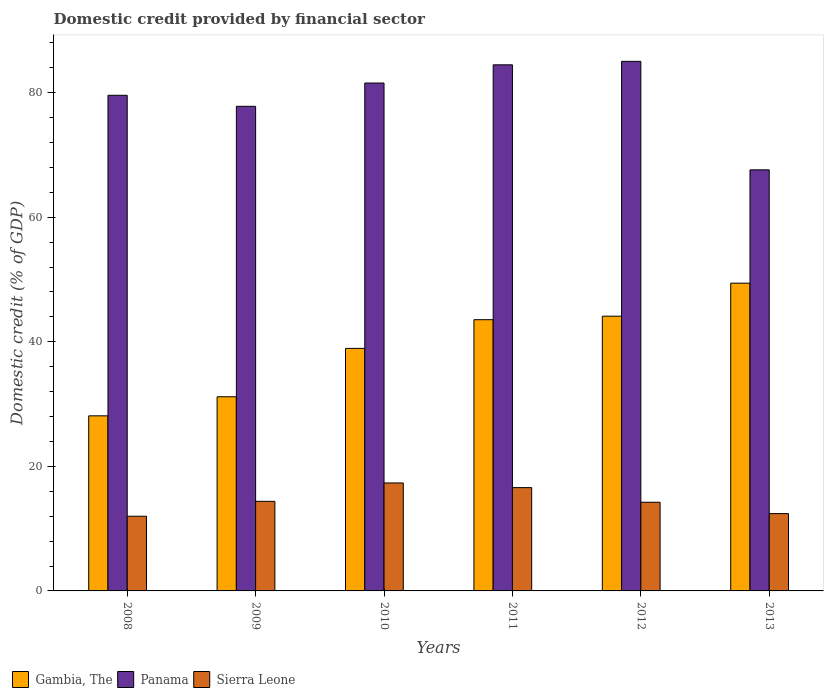Are the number of bars on each tick of the X-axis equal?
Provide a short and direct response. Yes. How many bars are there on the 1st tick from the left?
Keep it short and to the point. 3. How many bars are there on the 6th tick from the right?
Your response must be concise. 3. What is the label of the 4th group of bars from the left?
Ensure brevity in your answer.  2011. What is the domestic credit in Panama in 2010?
Your response must be concise. 81.54. Across all years, what is the maximum domestic credit in Sierra Leone?
Your response must be concise. 17.33. Across all years, what is the minimum domestic credit in Gambia, The?
Provide a short and direct response. 28.11. In which year was the domestic credit in Panama maximum?
Give a very brief answer. 2012. What is the total domestic credit in Sierra Leone in the graph?
Offer a terse response. 86.94. What is the difference between the domestic credit in Panama in 2011 and that in 2012?
Keep it short and to the point. -0.56. What is the difference between the domestic credit in Panama in 2009 and the domestic credit in Gambia, The in 2012?
Offer a terse response. 33.69. What is the average domestic credit in Sierra Leone per year?
Give a very brief answer. 14.49. In the year 2010, what is the difference between the domestic credit in Panama and domestic credit in Gambia, The?
Your answer should be very brief. 42.6. In how many years, is the domestic credit in Sierra Leone greater than 32 %?
Give a very brief answer. 0. What is the ratio of the domestic credit in Panama in 2008 to that in 2011?
Your answer should be very brief. 0.94. Is the domestic credit in Panama in 2012 less than that in 2013?
Offer a very short reply. No. What is the difference between the highest and the second highest domestic credit in Gambia, The?
Provide a short and direct response. 5.3. What is the difference between the highest and the lowest domestic credit in Gambia, The?
Make the answer very short. 21.3. Is the sum of the domestic credit in Gambia, The in 2009 and 2012 greater than the maximum domestic credit in Panama across all years?
Your answer should be compact. No. What does the 3rd bar from the left in 2010 represents?
Provide a short and direct response. Sierra Leone. What does the 2nd bar from the right in 2010 represents?
Provide a short and direct response. Panama. Is it the case that in every year, the sum of the domestic credit in Panama and domestic credit in Sierra Leone is greater than the domestic credit in Gambia, The?
Your response must be concise. Yes. How many bars are there?
Your answer should be very brief. 18. Are all the bars in the graph horizontal?
Make the answer very short. No. How many years are there in the graph?
Your response must be concise. 6. What is the difference between two consecutive major ticks on the Y-axis?
Provide a short and direct response. 20. Does the graph contain any zero values?
Your response must be concise. No. Where does the legend appear in the graph?
Provide a succinct answer. Bottom left. What is the title of the graph?
Your answer should be compact. Domestic credit provided by financial sector. Does "China" appear as one of the legend labels in the graph?
Offer a very short reply. No. What is the label or title of the Y-axis?
Offer a terse response. Domestic credit (% of GDP). What is the Domestic credit (% of GDP) of Gambia, The in 2008?
Provide a succinct answer. 28.11. What is the Domestic credit (% of GDP) of Panama in 2008?
Offer a very short reply. 79.57. What is the Domestic credit (% of GDP) in Sierra Leone in 2008?
Your answer should be compact. 11.99. What is the Domestic credit (% of GDP) in Gambia, The in 2009?
Make the answer very short. 31.17. What is the Domestic credit (% of GDP) of Panama in 2009?
Provide a short and direct response. 77.8. What is the Domestic credit (% of GDP) in Sierra Leone in 2009?
Your response must be concise. 14.39. What is the Domestic credit (% of GDP) of Gambia, The in 2010?
Your answer should be very brief. 38.94. What is the Domestic credit (% of GDP) in Panama in 2010?
Your answer should be very brief. 81.54. What is the Domestic credit (% of GDP) of Sierra Leone in 2010?
Your response must be concise. 17.33. What is the Domestic credit (% of GDP) in Gambia, The in 2011?
Keep it short and to the point. 43.55. What is the Domestic credit (% of GDP) of Panama in 2011?
Your answer should be very brief. 84.46. What is the Domestic credit (% of GDP) of Sierra Leone in 2011?
Give a very brief answer. 16.58. What is the Domestic credit (% of GDP) in Gambia, The in 2012?
Give a very brief answer. 44.11. What is the Domestic credit (% of GDP) of Panama in 2012?
Provide a succinct answer. 85.02. What is the Domestic credit (% of GDP) in Sierra Leone in 2012?
Make the answer very short. 14.24. What is the Domestic credit (% of GDP) in Gambia, The in 2013?
Offer a very short reply. 49.41. What is the Domestic credit (% of GDP) of Panama in 2013?
Your answer should be compact. 67.6. What is the Domestic credit (% of GDP) in Sierra Leone in 2013?
Keep it short and to the point. 12.41. Across all years, what is the maximum Domestic credit (% of GDP) of Gambia, The?
Ensure brevity in your answer.  49.41. Across all years, what is the maximum Domestic credit (% of GDP) in Panama?
Your response must be concise. 85.02. Across all years, what is the maximum Domestic credit (% of GDP) in Sierra Leone?
Keep it short and to the point. 17.33. Across all years, what is the minimum Domestic credit (% of GDP) of Gambia, The?
Your response must be concise. 28.11. Across all years, what is the minimum Domestic credit (% of GDP) in Panama?
Offer a terse response. 67.6. Across all years, what is the minimum Domestic credit (% of GDP) of Sierra Leone?
Give a very brief answer. 11.99. What is the total Domestic credit (% of GDP) of Gambia, The in the graph?
Make the answer very short. 235.28. What is the total Domestic credit (% of GDP) in Panama in the graph?
Keep it short and to the point. 476. What is the total Domestic credit (% of GDP) of Sierra Leone in the graph?
Give a very brief answer. 86.94. What is the difference between the Domestic credit (% of GDP) in Gambia, The in 2008 and that in 2009?
Give a very brief answer. -3.06. What is the difference between the Domestic credit (% of GDP) in Panama in 2008 and that in 2009?
Provide a short and direct response. 1.77. What is the difference between the Domestic credit (% of GDP) of Sierra Leone in 2008 and that in 2009?
Provide a succinct answer. -2.39. What is the difference between the Domestic credit (% of GDP) in Gambia, The in 2008 and that in 2010?
Provide a succinct answer. -10.83. What is the difference between the Domestic credit (% of GDP) in Panama in 2008 and that in 2010?
Give a very brief answer. -1.97. What is the difference between the Domestic credit (% of GDP) of Sierra Leone in 2008 and that in 2010?
Your answer should be compact. -5.34. What is the difference between the Domestic credit (% of GDP) in Gambia, The in 2008 and that in 2011?
Keep it short and to the point. -15.44. What is the difference between the Domestic credit (% of GDP) in Panama in 2008 and that in 2011?
Offer a very short reply. -4.89. What is the difference between the Domestic credit (% of GDP) of Sierra Leone in 2008 and that in 2011?
Offer a very short reply. -4.59. What is the difference between the Domestic credit (% of GDP) of Gambia, The in 2008 and that in 2012?
Provide a short and direct response. -16. What is the difference between the Domestic credit (% of GDP) in Panama in 2008 and that in 2012?
Offer a very short reply. -5.45. What is the difference between the Domestic credit (% of GDP) of Sierra Leone in 2008 and that in 2012?
Give a very brief answer. -2.24. What is the difference between the Domestic credit (% of GDP) of Gambia, The in 2008 and that in 2013?
Ensure brevity in your answer.  -21.3. What is the difference between the Domestic credit (% of GDP) of Panama in 2008 and that in 2013?
Make the answer very short. 11.97. What is the difference between the Domestic credit (% of GDP) of Sierra Leone in 2008 and that in 2013?
Make the answer very short. -0.42. What is the difference between the Domestic credit (% of GDP) in Gambia, The in 2009 and that in 2010?
Give a very brief answer. -7.77. What is the difference between the Domestic credit (% of GDP) in Panama in 2009 and that in 2010?
Provide a short and direct response. -3.74. What is the difference between the Domestic credit (% of GDP) in Sierra Leone in 2009 and that in 2010?
Offer a very short reply. -2.95. What is the difference between the Domestic credit (% of GDP) in Gambia, The in 2009 and that in 2011?
Ensure brevity in your answer.  -12.37. What is the difference between the Domestic credit (% of GDP) of Panama in 2009 and that in 2011?
Give a very brief answer. -6.66. What is the difference between the Domestic credit (% of GDP) in Sierra Leone in 2009 and that in 2011?
Offer a terse response. -2.2. What is the difference between the Domestic credit (% of GDP) of Gambia, The in 2009 and that in 2012?
Provide a succinct answer. -12.94. What is the difference between the Domestic credit (% of GDP) in Panama in 2009 and that in 2012?
Make the answer very short. -7.22. What is the difference between the Domestic credit (% of GDP) of Sierra Leone in 2009 and that in 2012?
Your response must be concise. 0.15. What is the difference between the Domestic credit (% of GDP) in Gambia, The in 2009 and that in 2013?
Provide a short and direct response. -18.24. What is the difference between the Domestic credit (% of GDP) in Panama in 2009 and that in 2013?
Offer a very short reply. 10.2. What is the difference between the Domestic credit (% of GDP) in Sierra Leone in 2009 and that in 2013?
Ensure brevity in your answer.  1.97. What is the difference between the Domestic credit (% of GDP) in Gambia, The in 2010 and that in 2011?
Provide a succinct answer. -4.61. What is the difference between the Domestic credit (% of GDP) of Panama in 2010 and that in 2011?
Ensure brevity in your answer.  -2.92. What is the difference between the Domestic credit (% of GDP) in Sierra Leone in 2010 and that in 2011?
Give a very brief answer. 0.75. What is the difference between the Domestic credit (% of GDP) in Gambia, The in 2010 and that in 2012?
Your response must be concise. -5.17. What is the difference between the Domestic credit (% of GDP) in Panama in 2010 and that in 2012?
Your answer should be very brief. -3.48. What is the difference between the Domestic credit (% of GDP) of Sierra Leone in 2010 and that in 2012?
Offer a very short reply. 3.1. What is the difference between the Domestic credit (% of GDP) of Gambia, The in 2010 and that in 2013?
Keep it short and to the point. -10.47. What is the difference between the Domestic credit (% of GDP) of Panama in 2010 and that in 2013?
Make the answer very short. 13.94. What is the difference between the Domestic credit (% of GDP) of Sierra Leone in 2010 and that in 2013?
Give a very brief answer. 4.92. What is the difference between the Domestic credit (% of GDP) in Gambia, The in 2011 and that in 2012?
Your response must be concise. -0.56. What is the difference between the Domestic credit (% of GDP) of Panama in 2011 and that in 2012?
Give a very brief answer. -0.56. What is the difference between the Domestic credit (% of GDP) of Sierra Leone in 2011 and that in 2012?
Give a very brief answer. 2.35. What is the difference between the Domestic credit (% of GDP) in Gambia, The in 2011 and that in 2013?
Give a very brief answer. -5.86. What is the difference between the Domestic credit (% of GDP) of Panama in 2011 and that in 2013?
Your answer should be compact. 16.86. What is the difference between the Domestic credit (% of GDP) in Sierra Leone in 2011 and that in 2013?
Give a very brief answer. 4.17. What is the difference between the Domestic credit (% of GDP) of Gambia, The in 2012 and that in 2013?
Your answer should be very brief. -5.3. What is the difference between the Domestic credit (% of GDP) in Panama in 2012 and that in 2013?
Provide a succinct answer. 17.42. What is the difference between the Domestic credit (% of GDP) of Sierra Leone in 2012 and that in 2013?
Make the answer very short. 1.82. What is the difference between the Domestic credit (% of GDP) in Gambia, The in 2008 and the Domestic credit (% of GDP) in Panama in 2009?
Your response must be concise. -49.69. What is the difference between the Domestic credit (% of GDP) in Gambia, The in 2008 and the Domestic credit (% of GDP) in Sierra Leone in 2009?
Give a very brief answer. 13.72. What is the difference between the Domestic credit (% of GDP) of Panama in 2008 and the Domestic credit (% of GDP) of Sierra Leone in 2009?
Keep it short and to the point. 65.19. What is the difference between the Domestic credit (% of GDP) of Gambia, The in 2008 and the Domestic credit (% of GDP) of Panama in 2010?
Offer a very short reply. -53.43. What is the difference between the Domestic credit (% of GDP) in Gambia, The in 2008 and the Domestic credit (% of GDP) in Sierra Leone in 2010?
Provide a short and direct response. 10.78. What is the difference between the Domestic credit (% of GDP) in Panama in 2008 and the Domestic credit (% of GDP) in Sierra Leone in 2010?
Your answer should be very brief. 62.24. What is the difference between the Domestic credit (% of GDP) of Gambia, The in 2008 and the Domestic credit (% of GDP) of Panama in 2011?
Keep it short and to the point. -56.35. What is the difference between the Domestic credit (% of GDP) in Gambia, The in 2008 and the Domestic credit (% of GDP) in Sierra Leone in 2011?
Ensure brevity in your answer.  11.53. What is the difference between the Domestic credit (% of GDP) in Panama in 2008 and the Domestic credit (% of GDP) in Sierra Leone in 2011?
Give a very brief answer. 62.99. What is the difference between the Domestic credit (% of GDP) of Gambia, The in 2008 and the Domestic credit (% of GDP) of Panama in 2012?
Provide a short and direct response. -56.91. What is the difference between the Domestic credit (% of GDP) of Gambia, The in 2008 and the Domestic credit (% of GDP) of Sierra Leone in 2012?
Your response must be concise. 13.87. What is the difference between the Domestic credit (% of GDP) in Panama in 2008 and the Domestic credit (% of GDP) in Sierra Leone in 2012?
Provide a succinct answer. 65.34. What is the difference between the Domestic credit (% of GDP) in Gambia, The in 2008 and the Domestic credit (% of GDP) in Panama in 2013?
Offer a very short reply. -39.49. What is the difference between the Domestic credit (% of GDP) of Gambia, The in 2008 and the Domestic credit (% of GDP) of Sierra Leone in 2013?
Give a very brief answer. 15.7. What is the difference between the Domestic credit (% of GDP) in Panama in 2008 and the Domestic credit (% of GDP) in Sierra Leone in 2013?
Offer a terse response. 67.16. What is the difference between the Domestic credit (% of GDP) in Gambia, The in 2009 and the Domestic credit (% of GDP) in Panama in 2010?
Give a very brief answer. -50.37. What is the difference between the Domestic credit (% of GDP) in Gambia, The in 2009 and the Domestic credit (% of GDP) in Sierra Leone in 2010?
Your answer should be compact. 13.84. What is the difference between the Domestic credit (% of GDP) in Panama in 2009 and the Domestic credit (% of GDP) in Sierra Leone in 2010?
Provide a succinct answer. 60.47. What is the difference between the Domestic credit (% of GDP) of Gambia, The in 2009 and the Domestic credit (% of GDP) of Panama in 2011?
Make the answer very short. -53.29. What is the difference between the Domestic credit (% of GDP) in Gambia, The in 2009 and the Domestic credit (% of GDP) in Sierra Leone in 2011?
Give a very brief answer. 14.59. What is the difference between the Domestic credit (% of GDP) in Panama in 2009 and the Domestic credit (% of GDP) in Sierra Leone in 2011?
Your answer should be very brief. 61.22. What is the difference between the Domestic credit (% of GDP) in Gambia, The in 2009 and the Domestic credit (% of GDP) in Panama in 2012?
Ensure brevity in your answer.  -53.85. What is the difference between the Domestic credit (% of GDP) in Gambia, The in 2009 and the Domestic credit (% of GDP) in Sierra Leone in 2012?
Give a very brief answer. 16.94. What is the difference between the Domestic credit (% of GDP) in Panama in 2009 and the Domestic credit (% of GDP) in Sierra Leone in 2012?
Offer a very short reply. 63.57. What is the difference between the Domestic credit (% of GDP) in Gambia, The in 2009 and the Domestic credit (% of GDP) in Panama in 2013?
Your response must be concise. -36.43. What is the difference between the Domestic credit (% of GDP) of Gambia, The in 2009 and the Domestic credit (% of GDP) of Sierra Leone in 2013?
Ensure brevity in your answer.  18.76. What is the difference between the Domestic credit (% of GDP) in Panama in 2009 and the Domestic credit (% of GDP) in Sierra Leone in 2013?
Give a very brief answer. 65.39. What is the difference between the Domestic credit (% of GDP) in Gambia, The in 2010 and the Domestic credit (% of GDP) in Panama in 2011?
Offer a terse response. -45.53. What is the difference between the Domestic credit (% of GDP) of Gambia, The in 2010 and the Domestic credit (% of GDP) of Sierra Leone in 2011?
Your answer should be very brief. 22.35. What is the difference between the Domestic credit (% of GDP) of Panama in 2010 and the Domestic credit (% of GDP) of Sierra Leone in 2011?
Offer a terse response. 64.96. What is the difference between the Domestic credit (% of GDP) in Gambia, The in 2010 and the Domestic credit (% of GDP) in Panama in 2012?
Keep it short and to the point. -46.08. What is the difference between the Domestic credit (% of GDP) of Gambia, The in 2010 and the Domestic credit (% of GDP) of Sierra Leone in 2012?
Your answer should be very brief. 24.7. What is the difference between the Domestic credit (% of GDP) of Panama in 2010 and the Domestic credit (% of GDP) of Sierra Leone in 2012?
Give a very brief answer. 67.3. What is the difference between the Domestic credit (% of GDP) in Gambia, The in 2010 and the Domestic credit (% of GDP) in Panama in 2013?
Provide a succinct answer. -28.66. What is the difference between the Domestic credit (% of GDP) of Gambia, The in 2010 and the Domestic credit (% of GDP) of Sierra Leone in 2013?
Your answer should be compact. 26.53. What is the difference between the Domestic credit (% of GDP) in Panama in 2010 and the Domestic credit (% of GDP) in Sierra Leone in 2013?
Your response must be concise. 69.13. What is the difference between the Domestic credit (% of GDP) of Gambia, The in 2011 and the Domestic credit (% of GDP) of Panama in 2012?
Keep it short and to the point. -41.48. What is the difference between the Domestic credit (% of GDP) in Gambia, The in 2011 and the Domestic credit (% of GDP) in Sierra Leone in 2012?
Your answer should be compact. 29.31. What is the difference between the Domestic credit (% of GDP) in Panama in 2011 and the Domestic credit (% of GDP) in Sierra Leone in 2012?
Your answer should be compact. 70.23. What is the difference between the Domestic credit (% of GDP) of Gambia, The in 2011 and the Domestic credit (% of GDP) of Panama in 2013?
Offer a terse response. -24.06. What is the difference between the Domestic credit (% of GDP) of Gambia, The in 2011 and the Domestic credit (% of GDP) of Sierra Leone in 2013?
Provide a succinct answer. 31.13. What is the difference between the Domestic credit (% of GDP) in Panama in 2011 and the Domestic credit (% of GDP) in Sierra Leone in 2013?
Make the answer very short. 72.05. What is the difference between the Domestic credit (% of GDP) of Gambia, The in 2012 and the Domestic credit (% of GDP) of Panama in 2013?
Offer a terse response. -23.49. What is the difference between the Domestic credit (% of GDP) of Gambia, The in 2012 and the Domestic credit (% of GDP) of Sierra Leone in 2013?
Make the answer very short. 31.69. What is the difference between the Domestic credit (% of GDP) of Panama in 2012 and the Domestic credit (% of GDP) of Sierra Leone in 2013?
Your response must be concise. 72.61. What is the average Domestic credit (% of GDP) of Gambia, The per year?
Your response must be concise. 39.21. What is the average Domestic credit (% of GDP) in Panama per year?
Your answer should be compact. 79.33. What is the average Domestic credit (% of GDP) in Sierra Leone per year?
Ensure brevity in your answer.  14.49. In the year 2008, what is the difference between the Domestic credit (% of GDP) in Gambia, The and Domestic credit (% of GDP) in Panama?
Your answer should be very brief. -51.46. In the year 2008, what is the difference between the Domestic credit (% of GDP) of Gambia, The and Domestic credit (% of GDP) of Sierra Leone?
Offer a very short reply. 16.12. In the year 2008, what is the difference between the Domestic credit (% of GDP) of Panama and Domestic credit (% of GDP) of Sierra Leone?
Your answer should be compact. 67.58. In the year 2009, what is the difference between the Domestic credit (% of GDP) in Gambia, The and Domestic credit (% of GDP) in Panama?
Keep it short and to the point. -46.63. In the year 2009, what is the difference between the Domestic credit (% of GDP) of Gambia, The and Domestic credit (% of GDP) of Sierra Leone?
Make the answer very short. 16.79. In the year 2009, what is the difference between the Domestic credit (% of GDP) in Panama and Domestic credit (% of GDP) in Sierra Leone?
Your answer should be very brief. 63.42. In the year 2010, what is the difference between the Domestic credit (% of GDP) of Gambia, The and Domestic credit (% of GDP) of Panama?
Offer a very short reply. -42.6. In the year 2010, what is the difference between the Domestic credit (% of GDP) in Gambia, The and Domestic credit (% of GDP) in Sierra Leone?
Provide a short and direct response. 21.6. In the year 2010, what is the difference between the Domestic credit (% of GDP) of Panama and Domestic credit (% of GDP) of Sierra Leone?
Provide a succinct answer. 64.21. In the year 2011, what is the difference between the Domestic credit (% of GDP) in Gambia, The and Domestic credit (% of GDP) in Panama?
Provide a short and direct response. -40.92. In the year 2011, what is the difference between the Domestic credit (% of GDP) in Gambia, The and Domestic credit (% of GDP) in Sierra Leone?
Your answer should be compact. 26.96. In the year 2011, what is the difference between the Domestic credit (% of GDP) of Panama and Domestic credit (% of GDP) of Sierra Leone?
Provide a succinct answer. 67.88. In the year 2012, what is the difference between the Domestic credit (% of GDP) of Gambia, The and Domestic credit (% of GDP) of Panama?
Provide a succinct answer. -40.91. In the year 2012, what is the difference between the Domestic credit (% of GDP) of Gambia, The and Domestic credit (% of GDP) of Sierra Leone?
Offer a very short reply. 29.87. In the year 2012, what is the difference between the Domestic credit (% of GDP) in Panama and Domestic credit (% of GDP) in Sierra Leone?
Your answer should be compact. 70.78. In the year 2013, what is the difference between the Domestic credit (% of GDP) of Gambia, The and Domestic credit (% of GDP) of Panama?
Offer a terse response. -18.19. In the year 2013, what is the difference between the Domestic credit (% of GDP) in Gambia, The and Domestic credit (% of GDP) in Sierra Leone?
Offer a terse response. 37. In the year 2013, what is the difference between the Domestic credit (% of GDP) of Panama and Domestic credit (% of GDP) of Sierra Leone?
Give a very brief answer. 55.19. What is the ratio of the Domestic credit (% of GDP) in Gambia, The in 2008 to that in 2009?
Your response must be concise. 0.9. What is the ratio of the Domestic credit (% of GDP) in Panama in 2008 to that in 2009?
Your answer should be very brief. 1.02. What is the ratio of the Domestic credit (% of GDP) of Sierra Leone in 2008 to that in 2009?
Provide a succinct answer. 0.83. What is the ratio of the Domestic credit (% of GDP) in Gambia, The in 2008 to that in 2010?
Provide a short and direct response. 0.72. What is the ratio of the Domestic credit (% of GDP) of Panama in 2008 to that in 2010?
Ensure brevity in your answer.  0.98. What is the ratio of the Domestic credit (% of GDP) in Sierra Leone in 2008 to that in 2010?
Keep it short and to the point. 0.69. What is the ratio of the Domestic credit (% of GDP) of Gambia, The in 2008 to that in 2011?
Offer a terse response. 0.65. What is the ratio of the Domestic credit (% of GDP) of Panama in 2008 to that in 2011?
Your response must be concise. 0.94. What is the ratio of the Domestic credit (% of GDP) in Sierra Leone in 2008 to that in 2011?
Ensure brevity in your answer.  0.72. What is the ratio of the Domestic credit (% of GDP) in Gambia, The in 2008 to that in 2012?
Provide a short and direct response. 0.64. What is the ratio of the Domestic credit (% of GDP) in Panama in 2008 to that in 2012?
Provide a succinct answer. 0.94. What is the ratio of the Domestic credit (% of GDP) in Sierra Leone in 2008 to that in 2012?
Your answer should be compact. 0.84. What is the ratio of the Domestic credit (% of GDP) in Gambia, The in 2008 to that in 2013?
Give a very brief answer. 0.57. What is the ratio of the Domestic credit (% of GDP) in Panama in 2008 to that in 2013?
Make the answer very short. 1.18. What is the ratio of the Domestic credit (% of GDP) in Gambia, The in 2009 to that in 2010?
Your answer should be compact. 0.8. What is the ratio of the Domestic credit (% of GDP) in Panama in 2009 to that in 2010?
Your response must be concise. 0.95. What is the ratio of the Domestic credit (% of GDP) of Sierra Leone in 2009 to that in 2010?
Provide a short and direct response. 0.83. What is the ratio of the Domestic credit (% of GDP) of Gambia, The in 2009 to that in 2011?
Offer a terse response. 0.72. What is the ratio of the Domestic credit (% of GDP) of Panama in 2009 to that in 2011?
Offer a very short reply. 0.92. What is the ratio of the Domestic credit (% of GDP) of Sierra Leone in 2009 to that in 2011?
Your answer should be very brief. 0.87. What is the ratio of the Domestic credit (% of GDP) in Gambia, The in 2009 to that in 2012?
Make the answer very short. 0.71. What is the ratio of the Domestic credit (% of GDP) in Panama in 2009 to that in 2012?
Your answer should be very brief. 0.92. What is the ratio of the Domestic credit (% of GDP) of Sierra Leone in 2009 to that in 2012?
Your response must be concise. 1.01. What is the ratio of the Domestic credit (% of GDP) in Gambia, The in 2009 to that in 2013?
Offer a very short reply. 0.63. What is the ratio of the Domestic credit (% of GDP) in Panama in 2009 to that in 2013?
Provide a succinct answer. 1.15. What is the ratio of the Domestic credit (% of GDP) in Sierra Leone in 2009 to that in 2013?
Your answer should be compact. 1.16. What is the ratio of the Domestic credit (% of GDP) of Gambia, The in 2010 to that in 2011?
Offer a terse response. 0.89. What is the ratio of the Domestic credit (% of GDP) in Panama in 2010 to that in 2011?
Offer a terse response. 0.97. What is the ratio of the Domestic credit (% of GDP) in Sierra Leone in 2010 to that in 2011?
Your answer should be compact. 1.05. What is the ratio of the Domestic credit (% of GDP) in Gambia, The in 2010 to that in 2012?
Make the answer very short. 0.88. What is the ratio of the Domestic credit (% of GDP) of Panama in 2010 to that in 2012?
Provide a succinct answer. 0.96. What is the ratio of the Domestic credit (% of GDP) of Sierra Leone in 2010 to that in 2012?
Offer a very short reply. 1.22. What is the ratio of the Domestic credit (% of GDP) in Gambia, The in 2010 to that in 2013?
Offer a terse response. 0.79. What is the ratio of the Domestic credit (% of GDP) in Panama in 2010 to that in 2013?
Offer a terse response. 1.21. What is the ratio of the Domestic credit (% of GDP) in Sierra Leone in 2010 to that in 2013?
Offer a very short reply. 1.4. What is the ratio of the Domestic credit (% of GDP) in Gambia, The in 2011 to that in 2012?
Your answer should be very brief. 0.99. What is the ratio of the Domestic credit (% of GDP) of Sierra Leone in 2011 to that in 2012?
Your answer should be compact. 1.17. What is the ratio of the Domestic credit (% of GDP) in Gambia, The in 2011 to that in 2013?
Your answer should be compact. 0.88. What is the ratio of the Domestic credit (% of GDP) in Panama in 2011 to that in 2013?
Ensure brevity in your answer.  1.25. What is the ratio of the Domestic credit (% of GDP) of Sierra Leone in 2011 to that in 2013?
Make the answer very short. 1.34. What is the ratio of the Domestic credit (% of GDP) of Gambia, The in 2012 to that in 2013?
Provide a succinct answer. 0.89. What is the ratio of the Domestic credit (% of GDP) of Panama in 2012 to that in 2013?
Keep it short and to the point. 1.26. What is the ratio of the Domestic credit (% of GDP) in Sierra Leone in 2012 to that in 2013?
Your answer should be very brief. 1.15. What is the difference between the highest and the second highest Domestic credit (% of GDP) in Gambia, The?
Provide a succinct answer. 5.3. What is the difference between the highest and the second highest Domestic credit (% of GDP) of Panama?
Provide a succinct answer. 0.56. What is the difference between the highest and the second highest Domestic credit (% of GDP) of Sierra Leone?
Your response must be concise. 0.75. What is the difference between the highest and the lowest Domestic credit (% of GDP) of Gambia, The?
Offer a very short reply. 21.3. What is the difference between the highest and the lowest Domestic credit (% of GDP) of Panama?
Give a very brief answer. 17.42. What is the difference between the highest and the lowest Domestic credit (% of GDP) of Sierra Leone?
Make the answer very short. 5.34. 